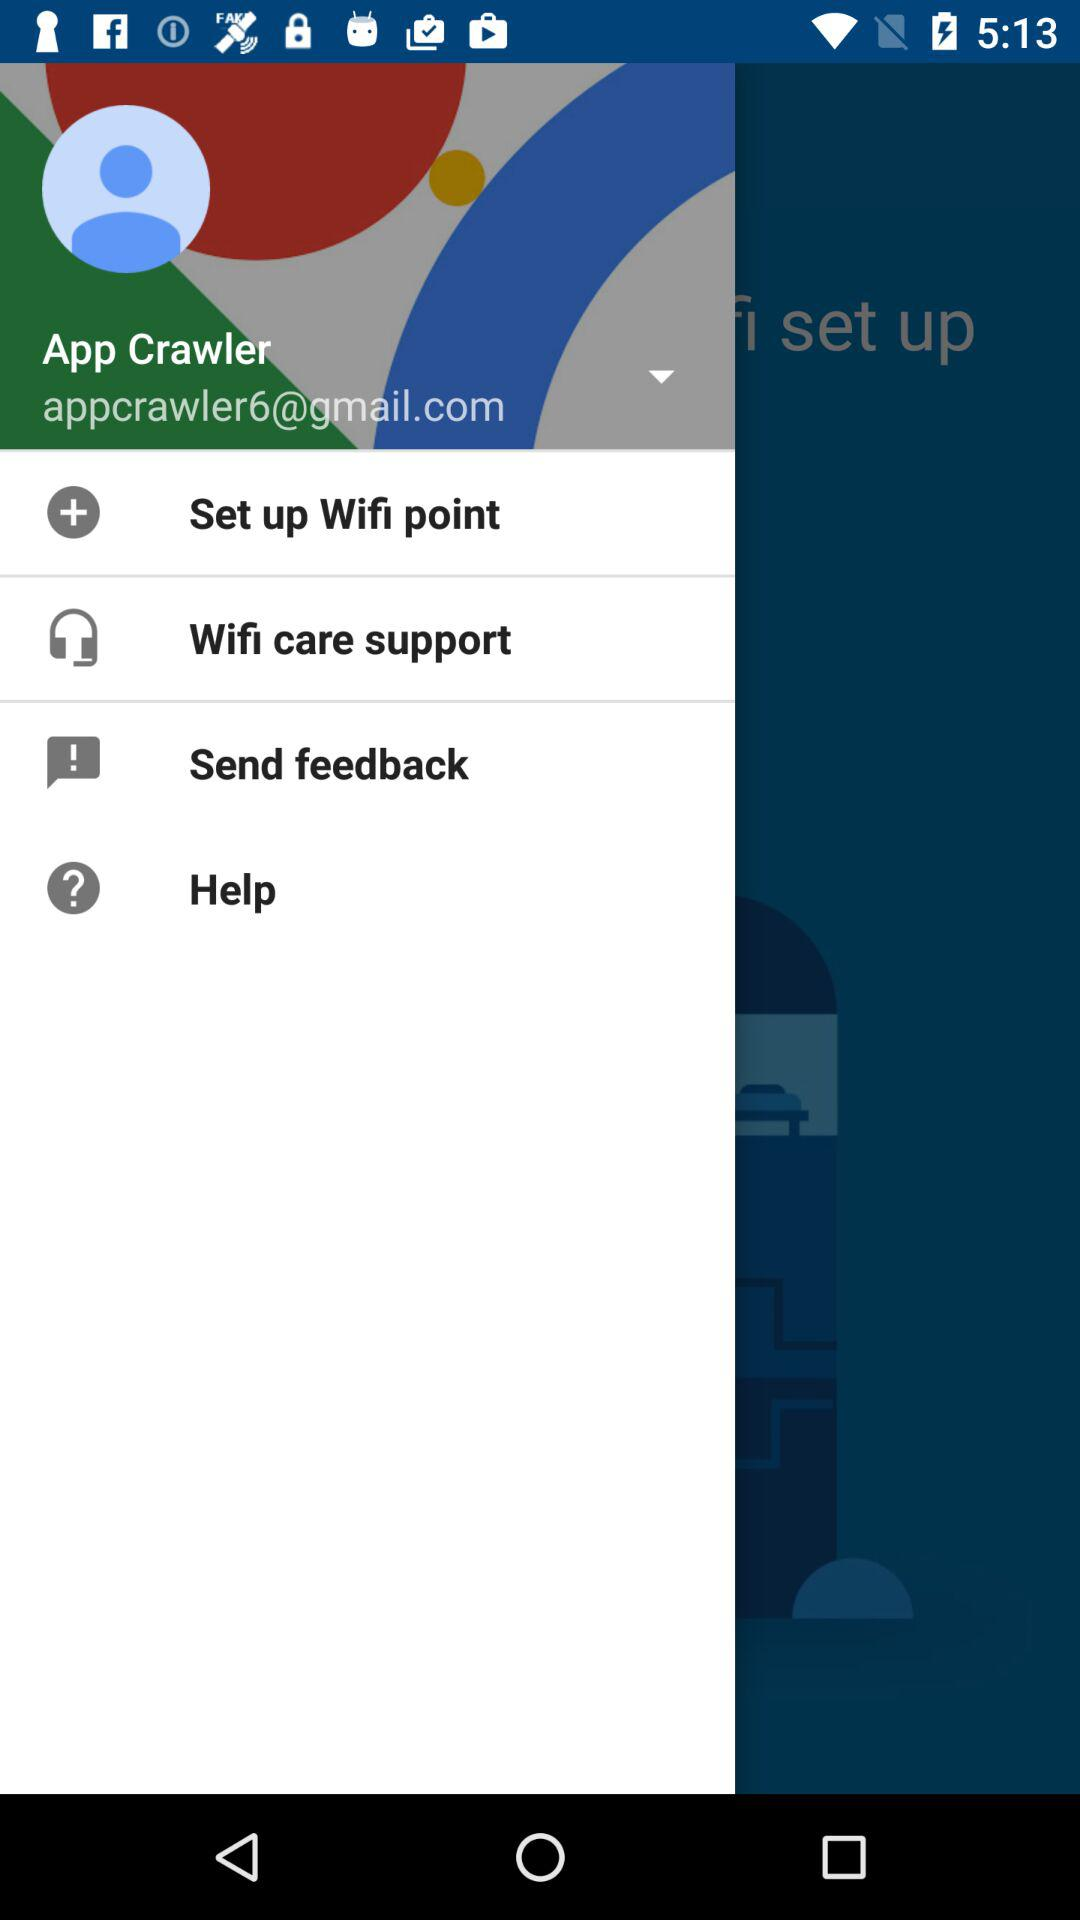What is the user name? The user name is "App Crawler". 